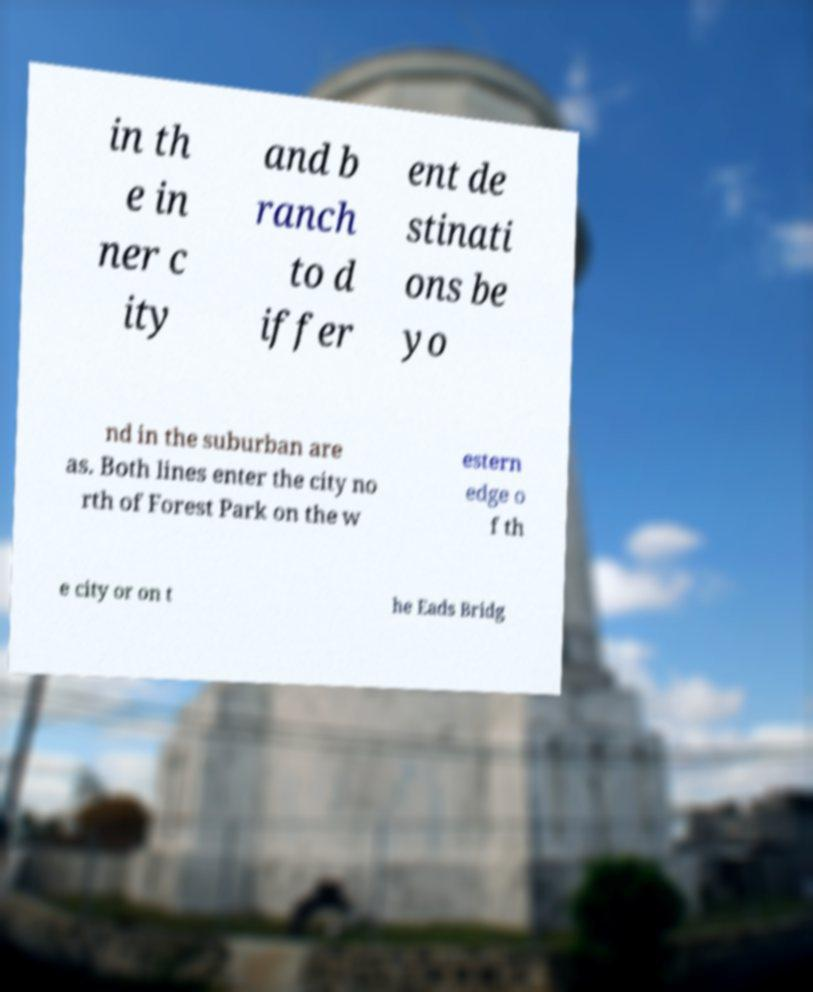There's text embedded in this image that I need extracted. Can you transcribe it verbatim? in th e in ner c ity and b ranch to d iffer ent de stinati ons be yo nd in the suburban are as. Both lines enter the city no rth of Forest Park on the w estern edge o f th e city or on t he Eads Bridg 